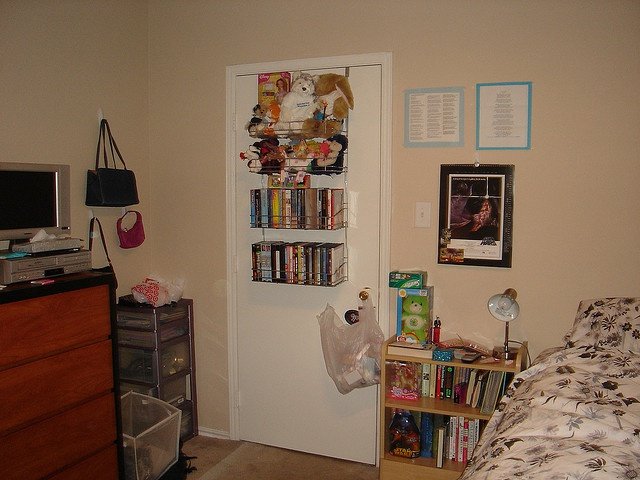Describe the objects in this image and their specific colors. I can see bed in gray and tan tones, tv in gray, black, and maroon tones, book in gray, black, and maroon tones, handbag in gray, black, and maroon tones, and teddy bear in gray, maroon, and tan tones in this image. 